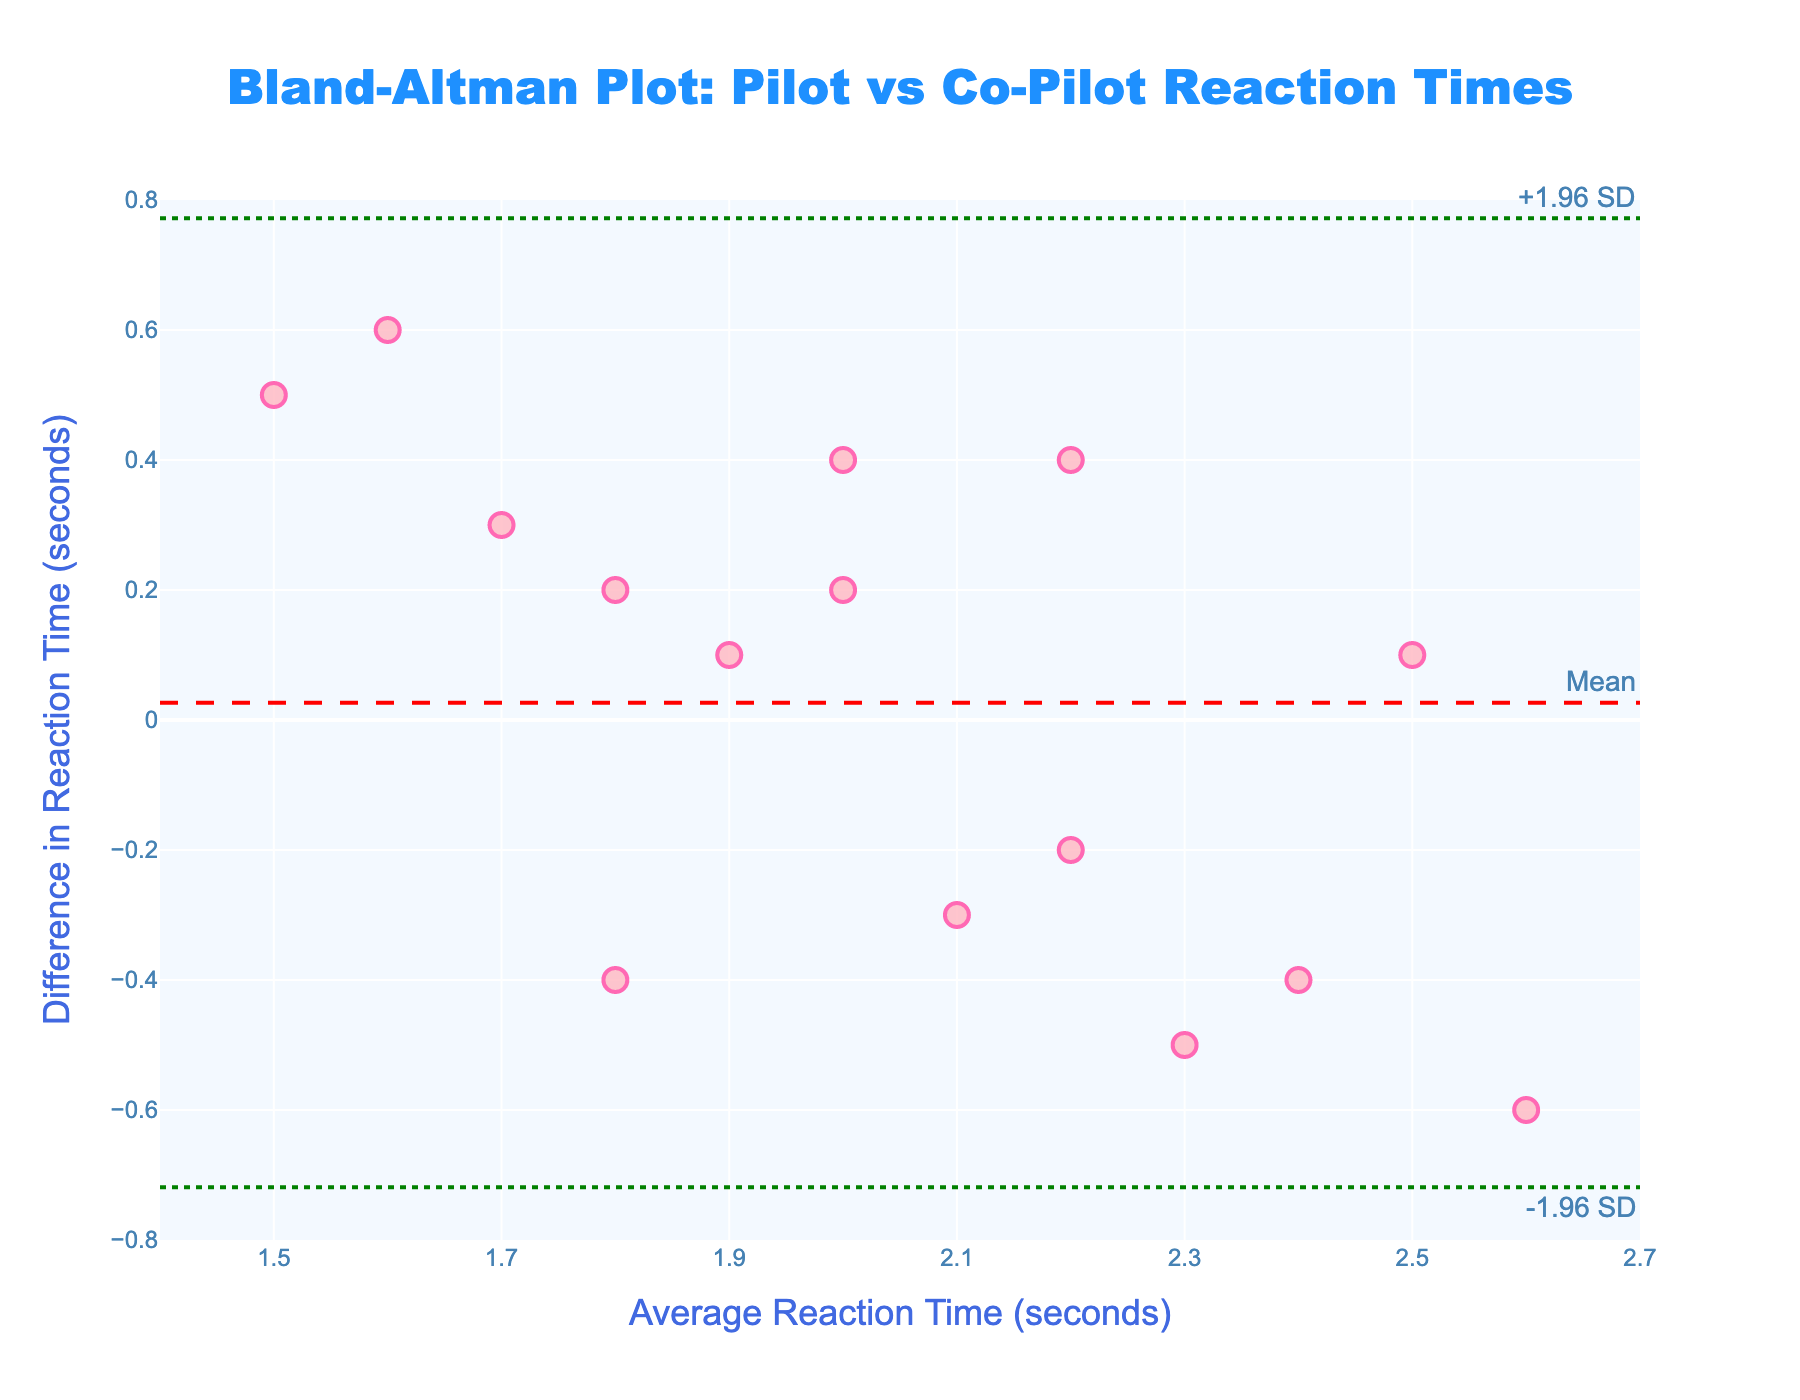How many data points are plotted in the figure? The figure shows a scatter plot with individual data points marked. By counting the number of markers in the plot, we can determine the number of data points.
Answer: 15 What is the title of the plot? The title is usually prominently displayed at the top of the figure, typically in a larger and bold font.
Answer: Bland-Altman Plot: Pilot vs Co-Pilot Reaction Times What is the range of the y-axis? The range of the y-axis can be determined by looking at the minimum and maximum values marked on the axis. The figure shows tick marks from -0.8 to 0.8.
Answer: -0.8 to 0.8 What do the dashed lines represent? The dashed lines are commonly used to indicate statistical measures in a Bland-Altman plot. In this figure, the central dashed red line represents the mean difference, and the dotted green lines represent the limits of agreement (+1.96 SD and -1.96 SD).
Answer: Mean, +1.96 SD, -1.96 SD What is the mean difference in reaction times between pilot and co-pilot? The mean difference is indicated by the central red dashed line, usually annotated with the label "Mean" on the plot.
Answer: 0 What is the approximate difference in reaction times for an average of 2.0 seconds? To estimate this, locate the point on the x-axis corresponding to 2.0 seconds and then find the y-coordinate value, which represents the difference.
Answer: 0.4 How many data points fall outside the limits of agreement? Examine the plotted points and count how many lie above the upper green dotted line (+1.96 SD) or below the lower green dotted line (-1.96 SD).
Answer: 0 Which data point shows the highest positive difference for reaction times? Identify the data point plotted the highest above the x-axis, as this represents the largest positive difference.
Answer: Capt. Nicole Clark and FO Ryan Murphy Is there a tendency for higher average reaction times to show larger differences? By visually inspecting the spread of data points along the x-axis (average reaction time) and their corresponding y-values (differences), we can assess if larger averages relate to larger differences.
Answer: No clear tendency What does it imply if a data point falls close to the mean difference line? Points near the mean difference line indicate that the reaction times of the pilot and co-pilot were very similar, showing low discrepancy.
Answer: Reaction times are similar 